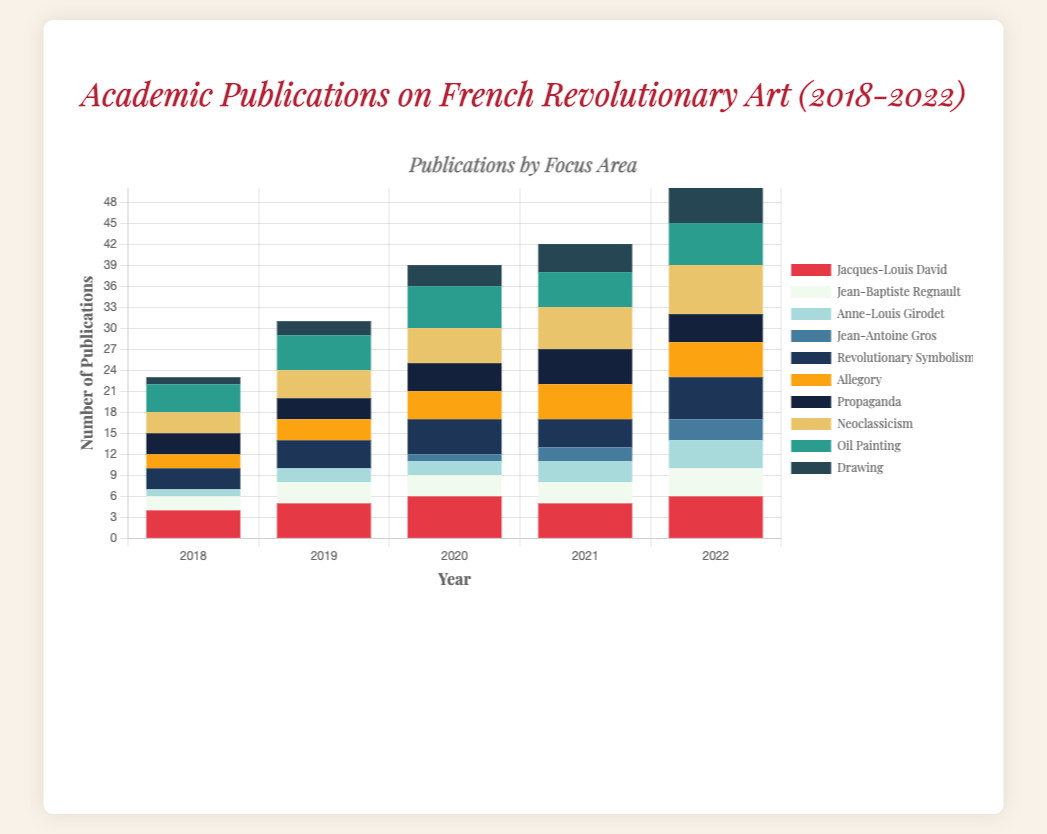Which artist had the most publications in 2022? Looking at the colors associated with each artist in 2022, "Jacques-Louis David" has the most publications as indicated by his red bar being the tallest.
Answer: Jacques-Louis David How did the number of publications on "Neoclassicism" change from 2018 to 2022? In 2018, publications on "Neoclassicism" were 3. By 2022, this increased to 7. Calculating the difference: 7 - 3 = 4 publications.
Answer: Increased by 4 Compare the number of publications on "Jacques-Louis David" and "Revolutionary Symbolism" in 2020. Who had more, and by how much? In 2020, "Jacques-Louis David" had 6 publications whereas "Revolutionary Symbolism" had 5. The difference is 6 - 5 = 1 publication.
Answer: Jacques-Louis David by 1 What was the total number of publications for "Techniques" in 2020? Summing up the publications for "Neoclassicism" (5), "Oil Painting" (6), and "Drawing" (3) in 2020: 5 + 6 + 3 = 14 publications.
Answer: 14 Analyses the trend in publications on "Allegory" from 2018 to 2022? Publications on "Allegory" were 2 in 2018, increased to 3 in 2019, 4 in 2020, peaked at 5 in 2021, and remained 5 in 2022. Overall, there is an upward trend.
Answer: Upward trend Which "Techniques" focus area saw the least publications in 2019, and how many were there? In 2019, "Drawing" had the least publications among the techniques, with only 2 publications.
Answer: Drawing, 2 How many total publications were made on "Themes" in 2021? Summing up the publications for "Revolutionary Symbolism" (4), "Allegory" (5), and "Propaganda" (5) in 2021: 4 + 5 + 5 = 14 publications.
Answer: 14 What's the difference in the total publications for "Artists" between 2018 and 2022? In 2018, the sum of publications for "Artists" is 4 + 2 + 1 = 7. In 2022, it is 6 + 4 + 4 + 3 = 17. The difference is 17 - 7 = 10 publications.
Answer: 10 Which year had the highest total publications for "Oil Painting"? Checking the totals for "Oil Painting" from 2018 to 2022: 4 (2018), 5 (2019), 6 (2020), 5 (2021), 6 (2022). 2020 and 2022 had the highest total, both with 6 publications.
Answer: 2020 and 2022 What's the average number of publications on "Jean-Baptiste Regnault" over the five years? The total number of publications for "Jean-Baptiste Regnault" from 2018 to 2022 is 2 + 3 + 3 + 3 + 4 = 15. Dividing by 5 years: 15 / 5 = 3.
Answer: 3 